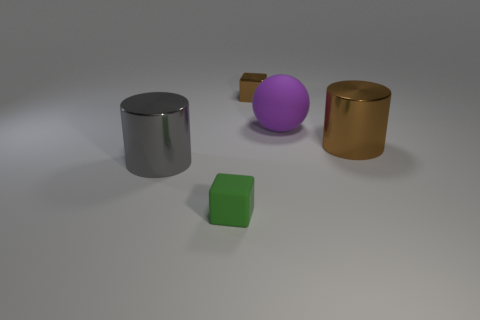Are there any other things that have the same shape as the tiny green object?
Offer a terse response. Yes. There is a metal object that is to the right of the purple matte object; what shape is it?
Give a very brief answer. Cylinder. What shape is the brown object behind the metallic thing that is to the right of the small block that is to the right of the green matte object?
Your answer should be compact. Cube. What number of things are large brown metal things or gray cylinders?
Provide a succinct answer. 2. There is a brown thing that is behind the big purple sphere; is its shape the same as the matte thing that is in front of the big gray shiny cylinder?
Your answer should be very brief. Yes. What number of brown objects are both in front of the purple thing and to the left of the large purple ball?
Give a very brief answer. 0. What number of other things are the same size as the gray cylinder?
Provide a short and direct response. 2. What material is the thing that is behind the brown metallic cylinder and to the left of the purple matte sphere?
Ensure brevity in your answer.  Metal. There is a big matte object; does it have the same color as the small thing in front of the brown block?
Give a very brief answer. No. There is another object that is the same shape as the big gray object; what is its size?
Give a very brief answer. Large. 